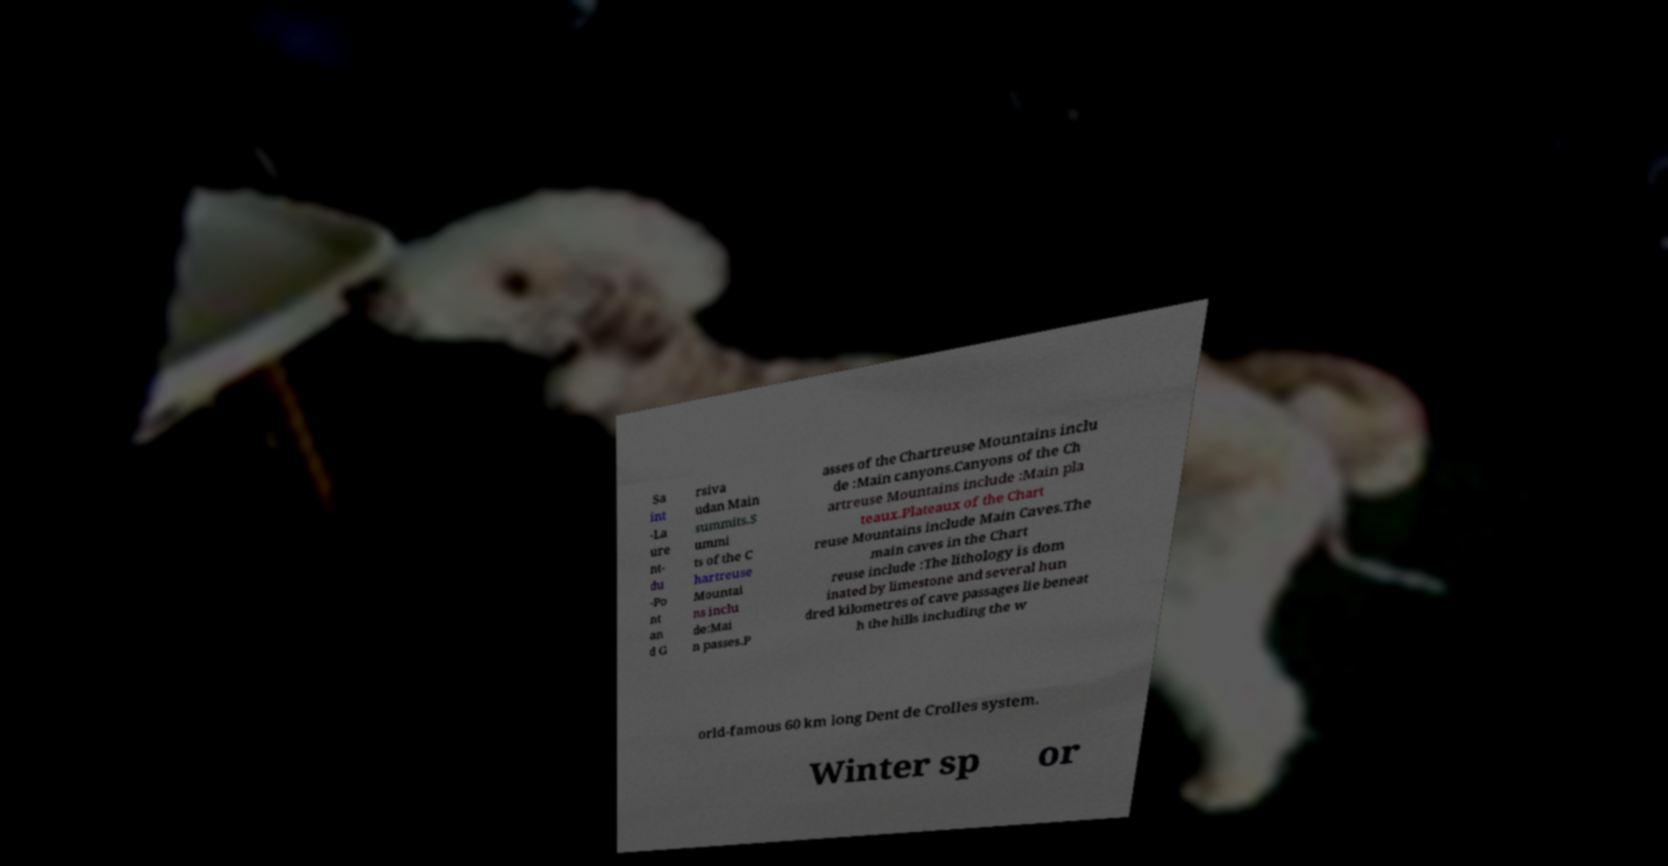Please identify and transcribe the text found in this image. Sa int -La ure nt- du -Po nt an d G rsiva udan Main summits.S ummi ts of the C hartreuse Mountai ns inclu de:Mai n passes.P asses of the Chartreuse Mountains inclu de :Main canyons.Canyons of the Ch artreuse Mountains include :Main pla teaux.Plateaux of the Chart reuse Mountains include Main Caves.The main caves in the Chart reuse include :The lithology is dom inated by limestone and several hun dred kilometres of cave passages lie beneat h the hills including the w orld-famous 60 km long Dent de Crolles system. Winter sp or 